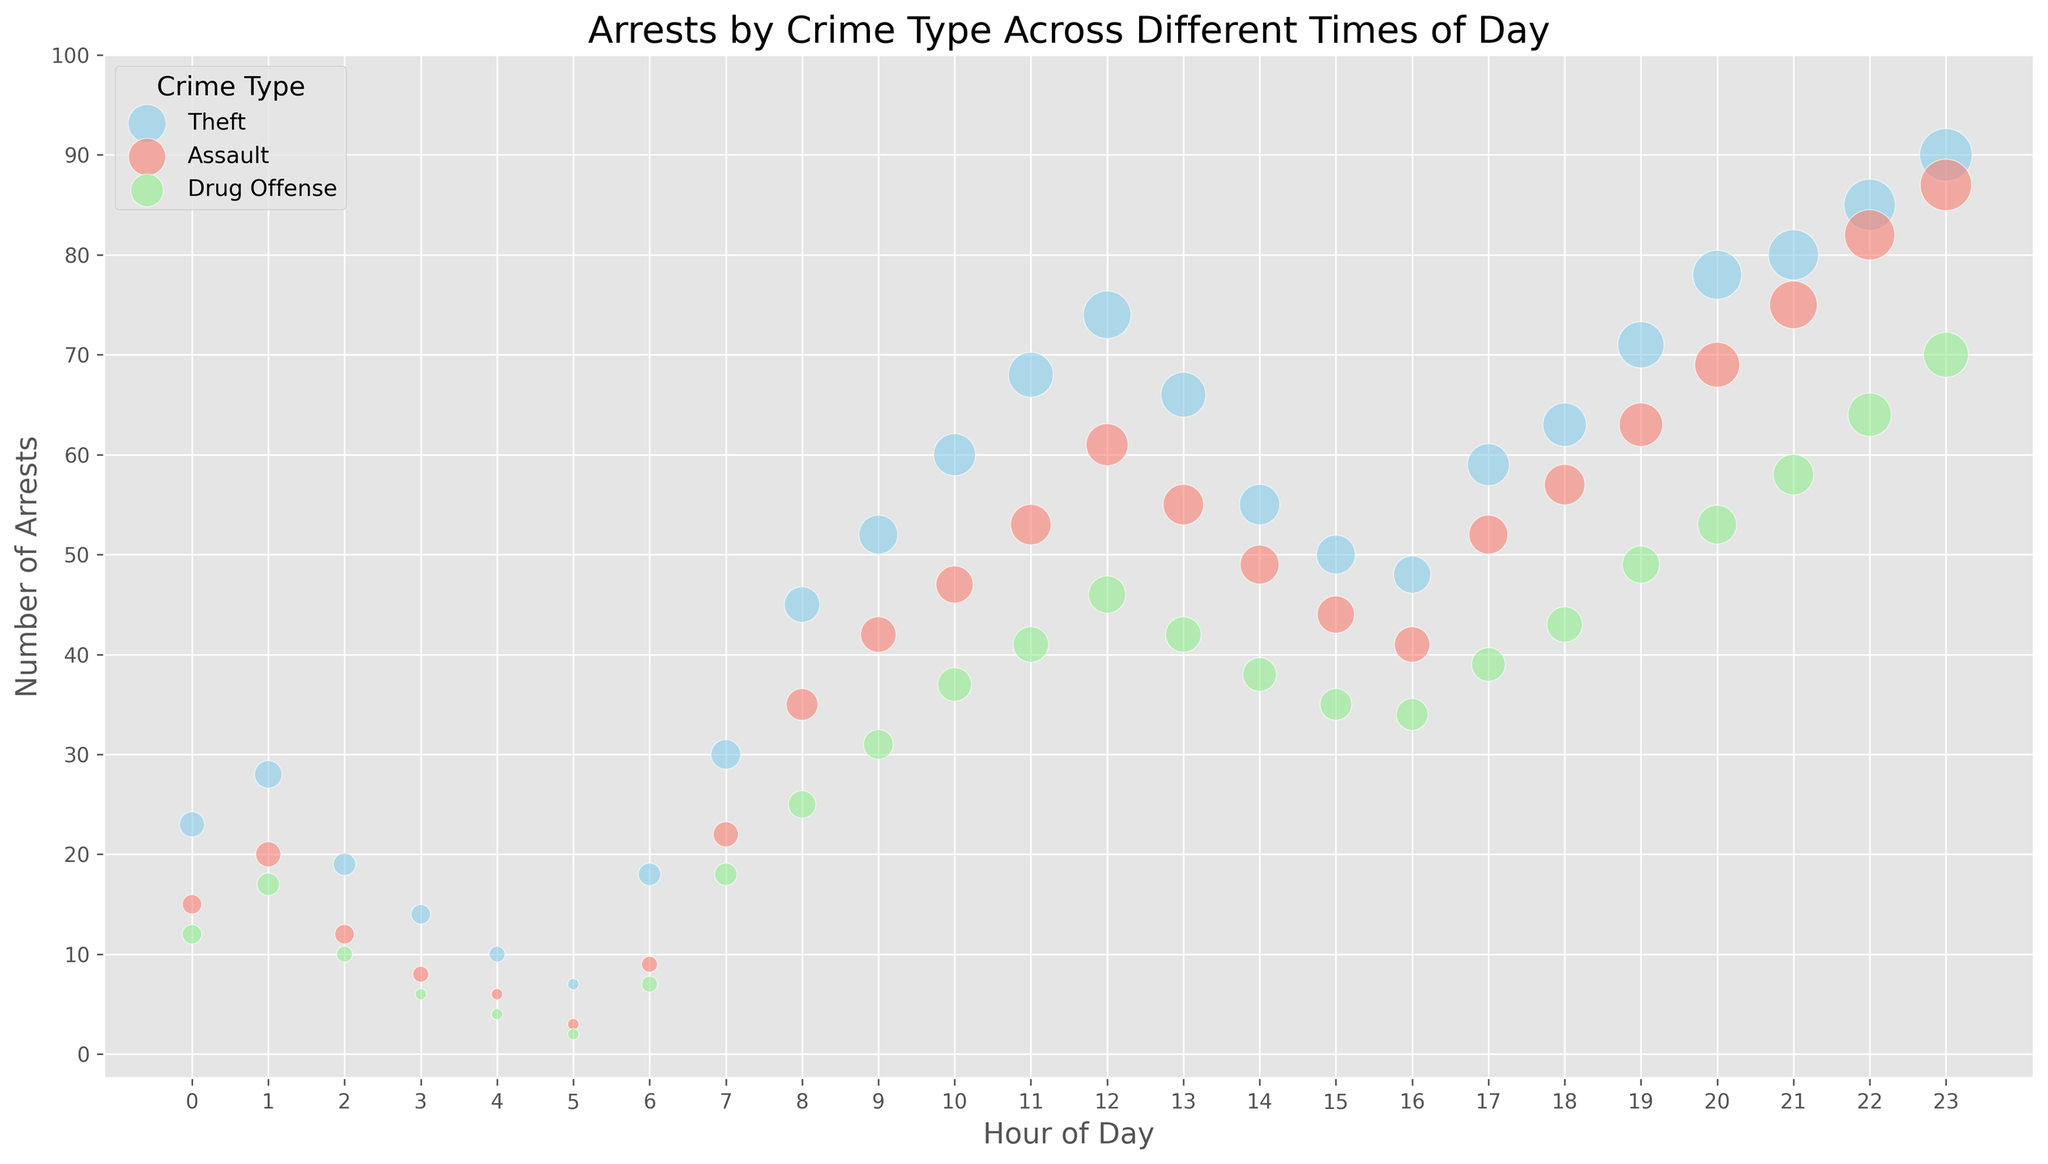what time of day has the highest number of arrests for theft? To find the hour with the most arrests for theft, look at the bubble sizes for theft and identify the largest one. The largest bubble for theft is at hour 23 with 90 arrests.
Answer: 23 which crime type has the most arrests at 8 AM? Compare the bubble sizes for each crime type at 8 AM. For theft, there are 45 arrests; for assault, there are 35 arrests; and for drug offenses, there are 25 arrests. Theft has the most arrests at this time.
Answer: theft during which hours do theft arrests exceed assault arrests? Compare the bubble sizes for theft and assault for each hour. Theft arrests exceed assault arrests at hours (0-2), (4-7), (10), (11), (13-16), (18), (19), (21-23).
Answer: 0-2, 4-7, 10, 11, 13-16, 18, 19, 21-23 what is the average number of arrests for drug offenses during the day (6 AM to 6 PM)? Sum the arrests for drug offenses from hour 6 to hour 18 and divide by the number of hours (13). The arrests are 7, 18, 25, 31, 37, 41, 46, 42, 38, 35, 34, 39, 43; which totals to 436. Then, 436 divided by 13 equals approximately 33.54.
Answer: 33.54 how does the pattern of arrests for assault change throughout the day? Examine the trend in bubble sizes for assault throughout 24 hours. Assault arrests start low in early hours, gradually increase, peak at night, and slowly decrease again.
Answer: Increase, peak at night, decrease which hour has the smallest number of arrests for all crime types combined? Sum arrests for every hour across all crime types and identify the hour with the smallest total. The hour with the smallest combined number of arrests is 5 AM (7+3+2) with 12 arrests.
Answer: 5 at what times do theft arrests experience significant increases? Identify hours with noticeable increases in bubble sizes. Significant increases in theft arrests are observed at hours 8, 10, 12, 14, 19, 21, and 22.
Answer: 8, 10, 12, 14, 19, 21, 22 what is the difference between the number of arrests for theft and drug offenses at 10 AM? Look at the arrests for theft at 10 AM (60) and drug offenses at 10 AM (37), then calculate the difference: 60 - 37 = 23.
Answer: 23 during which hour are the bubbles for assault and theft the same size? Identify the hours where the bubble size of assaults is equal to that of thefts. This happens at hour 7, where both have bubble sizes of 7.
Answer: 7 